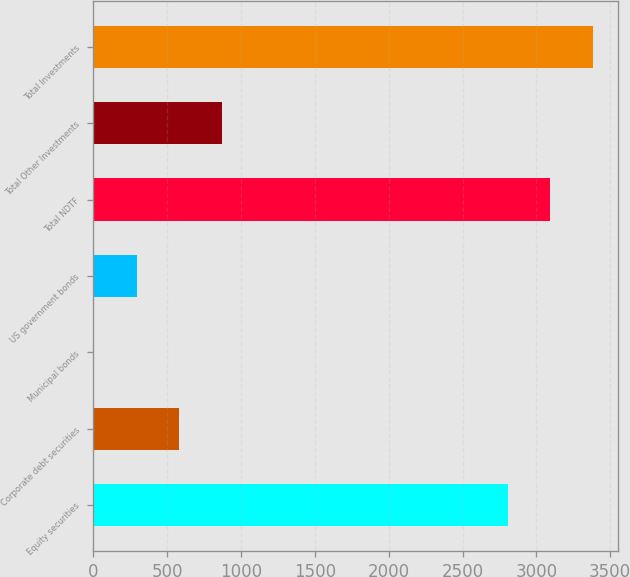<chart> <loc_0><loc_0><loc_500><loc_500><bar_chart><fcel>Equity securities<fcel>Corporate debt securities<fcel>Municipal bonds<fcel>US government bonds<fcel>Total NDTF<fcel>Total Other Investments<fcel>Total Investments<nl><fcel>2805<fcel>583<fcel>4<fcel>293.5<fcel>3094.5<fcel>872.5<fcel>3384<nl></chart> 